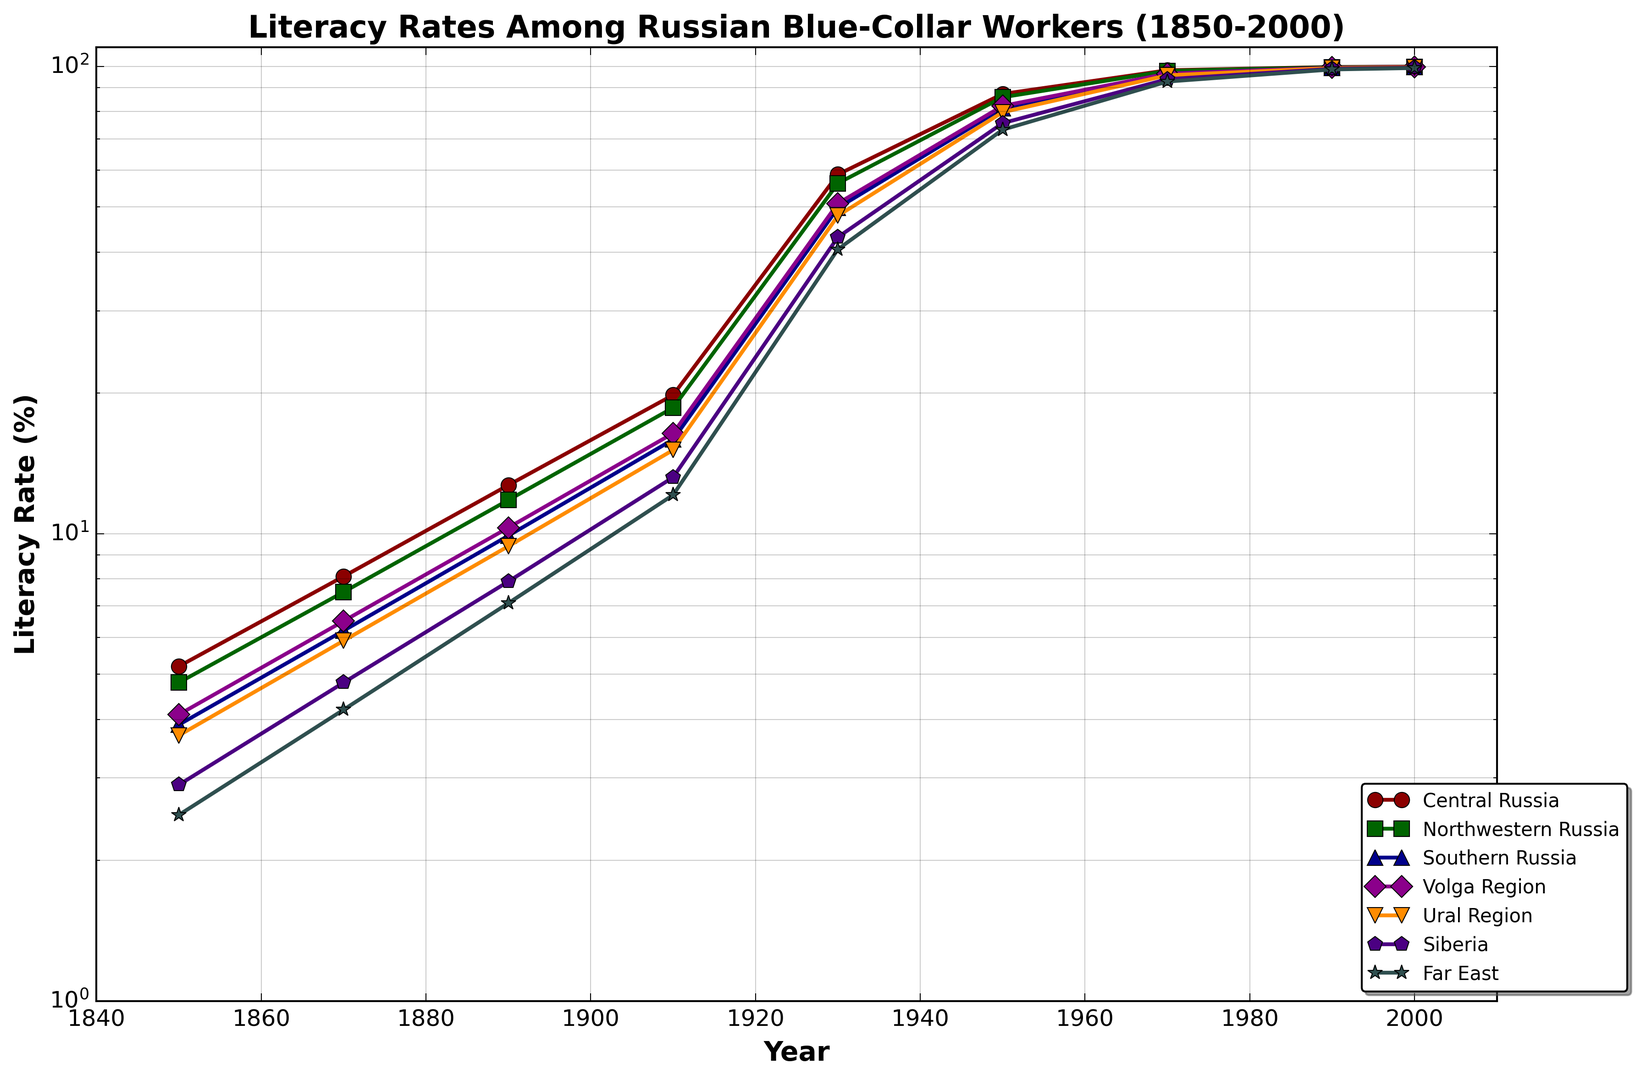What is the overall trend of literacy rates in all regions between 1850 and 2000? The overall trend shows a significant increase in literacy rates across all regions from 1850 to 2000. Initially, literacy rates were low (ranging from 2.5% to 5.2% in 1850) but saw a consistent rise over the years, reaching almost 100% by the year 2000.
Answer: Steadily increasing Which region had the highest literacy rate in 1850? In 1850, Central Russia had the highest literacy rate at 5.2%, as indicated by the figure.
Answer: Central Russia By how much did the literacy rate increase in Central Russia from 1850 to 1910? The literacy rate in Central Russia was 5.2% in 1850 and increased to 19.8% by 1910. The increase is calculated as 19.8 - 5.2 = 14.6 percentage points.
Answer: 14.6 percentage points How does the literacy rate of the Volga Region in 1970 compare to that in 1930? The literacy rate in the Volga Region was 50.9% in 1930 and increased to 96.5% in 1970. This shows a significant rise over this 40-year period.
Answer: Increased significantly Which region had the smallest increase in literacy rate between 1930 and 1950? By comparing the literacy rates in 1930 and 1950 for each region, the Far East had the smallest increase: from 40.6% in 1930 to 73.2% in 1950, an increase of 32.6 percentage points.
Answer: Far East What color is used to represent the Northwestern Russia region in the plot? The figure uses specific colors for each region, and Northwestern Russia is represented by green.
Answer: Green Between 1910 and 1930, which two regions showed the most similar increase in literacy rates? By looking at the data, Southern Russia increased from 15.9% to 49.8% (33.9 percentage points), and Volga Region increased from 16.4% to 50.9% (34.5 percentage points). These two regions had very similar increases.
Answer: Southern Russia and Volga Region Did any region reach a literacy rate close to 100% before 1990? Yes, by 1970, regions such as Central Russia (98.1%), Northwestern Russia (97.8%), Southern Russia (96.2%), and Volga Region (96.5%) had literacy rates close to 100%.
Answer: Yes In the final year of the data (2000), which region had the lowest literacy rate, and what was it? In the year 2000, the Far East had the lowest literacy rate at 99.2%, as shown in the figure.
Answer: Far East (99.2%) By how many percentage points did literacy improve in Southern Russia from 1890 to 2000? The literacy rate in Southern Russia was 9.9% in 1890 and improved to 99.7% by 2000. The increase is calculated as 99.7 - 9.9 = 89.8 percentage points.
Answer: 89.8 percentage points 